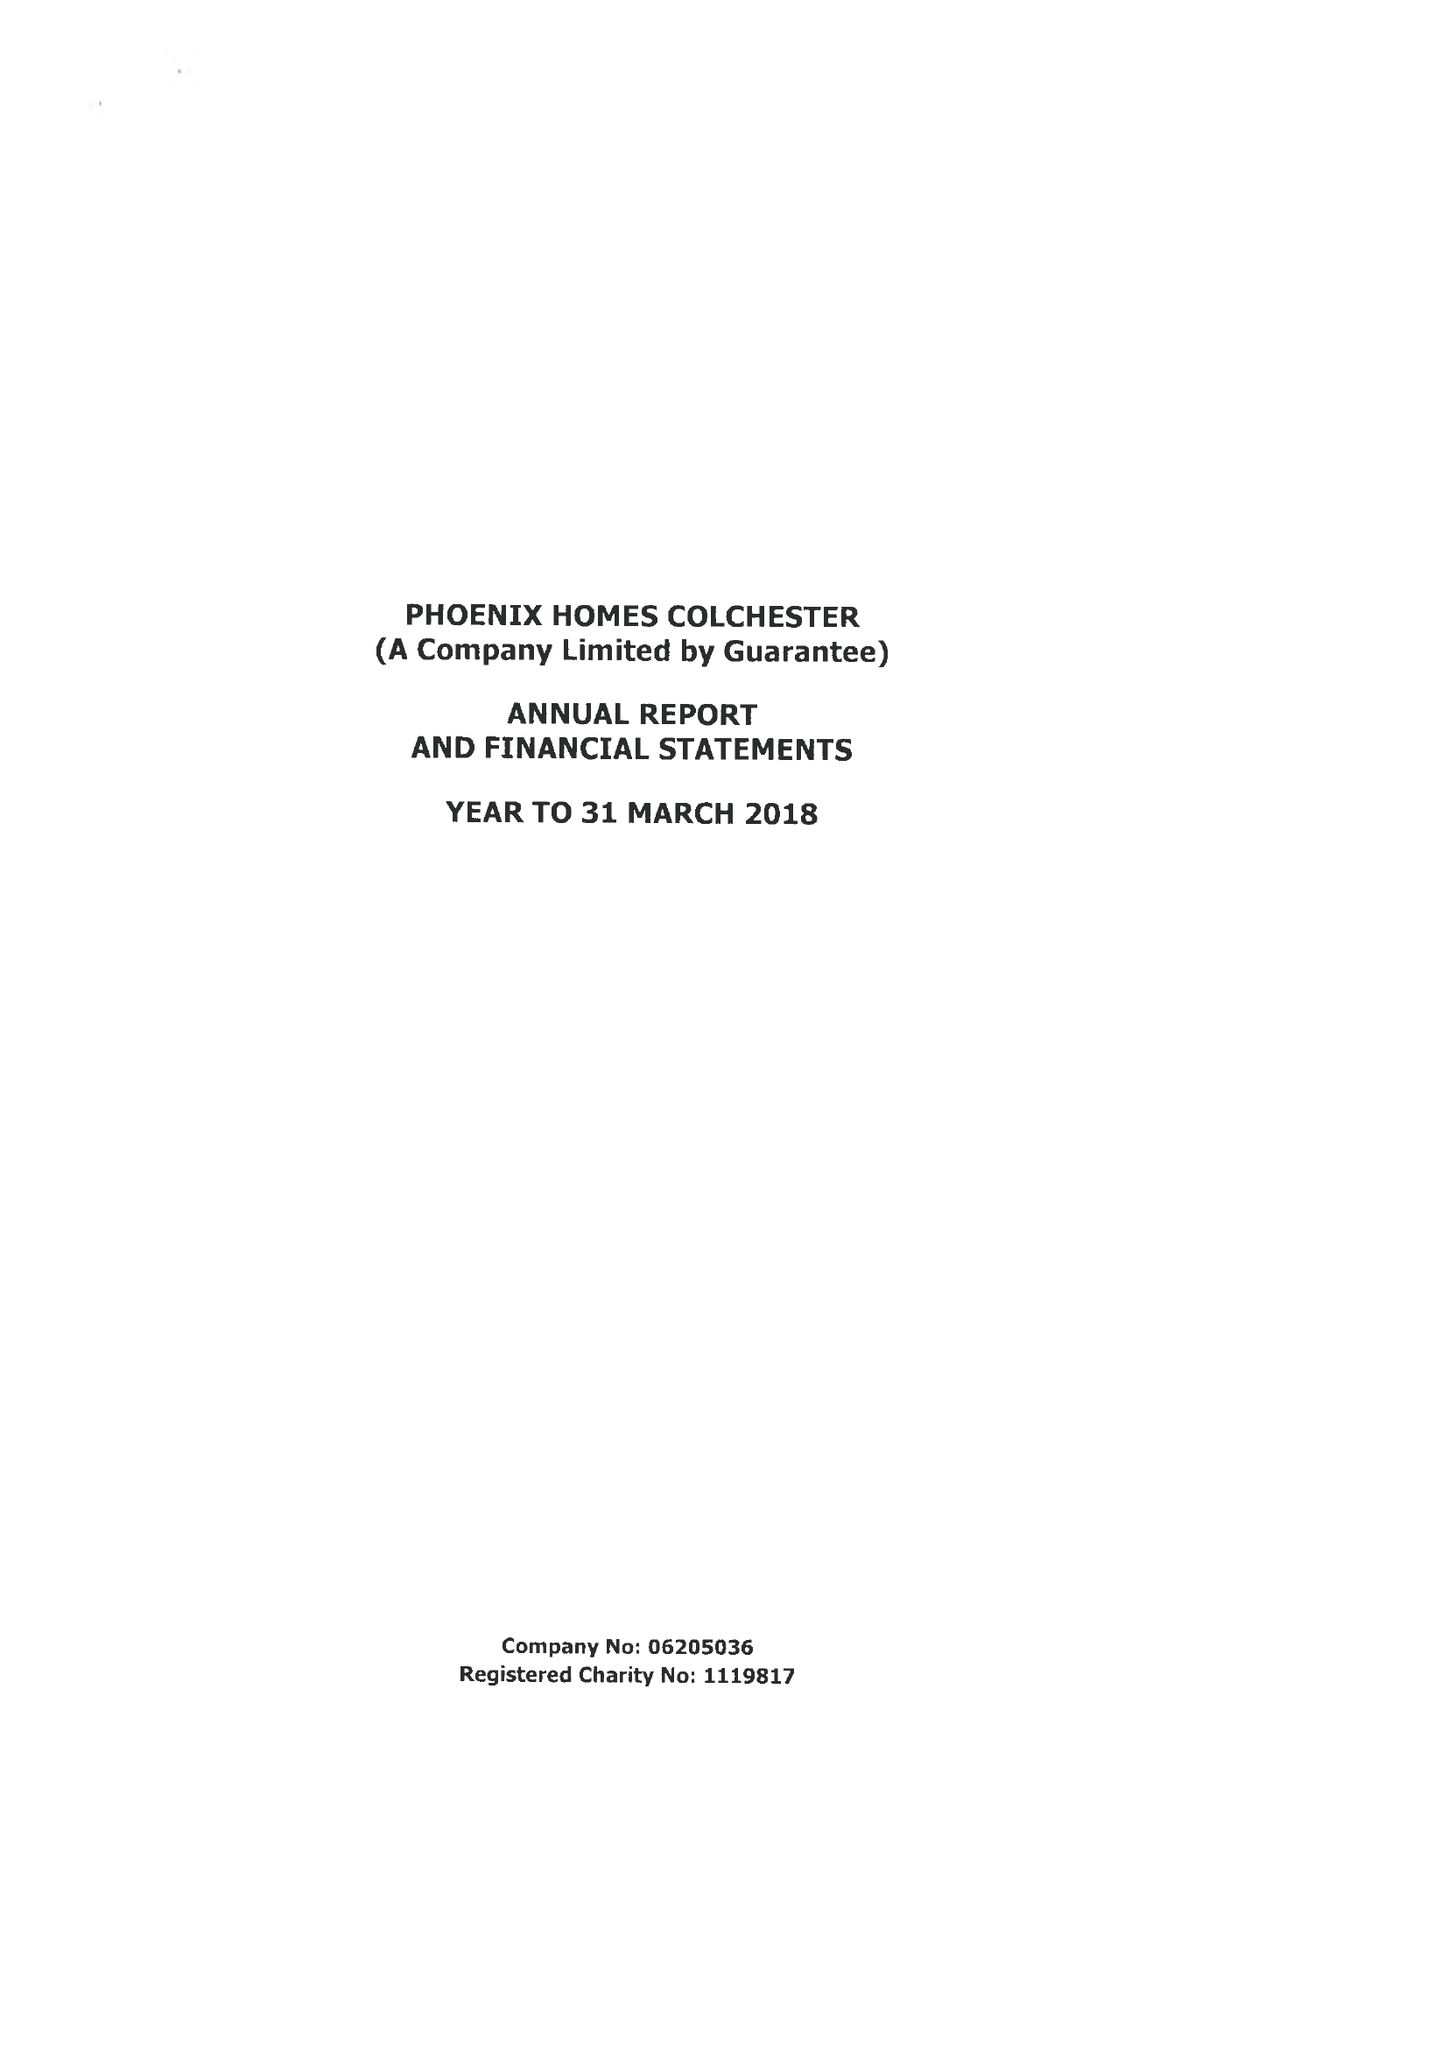What is the value for the income_annually_in_british_pounds?
Answer the question using a single word or phrase. 342535.00 